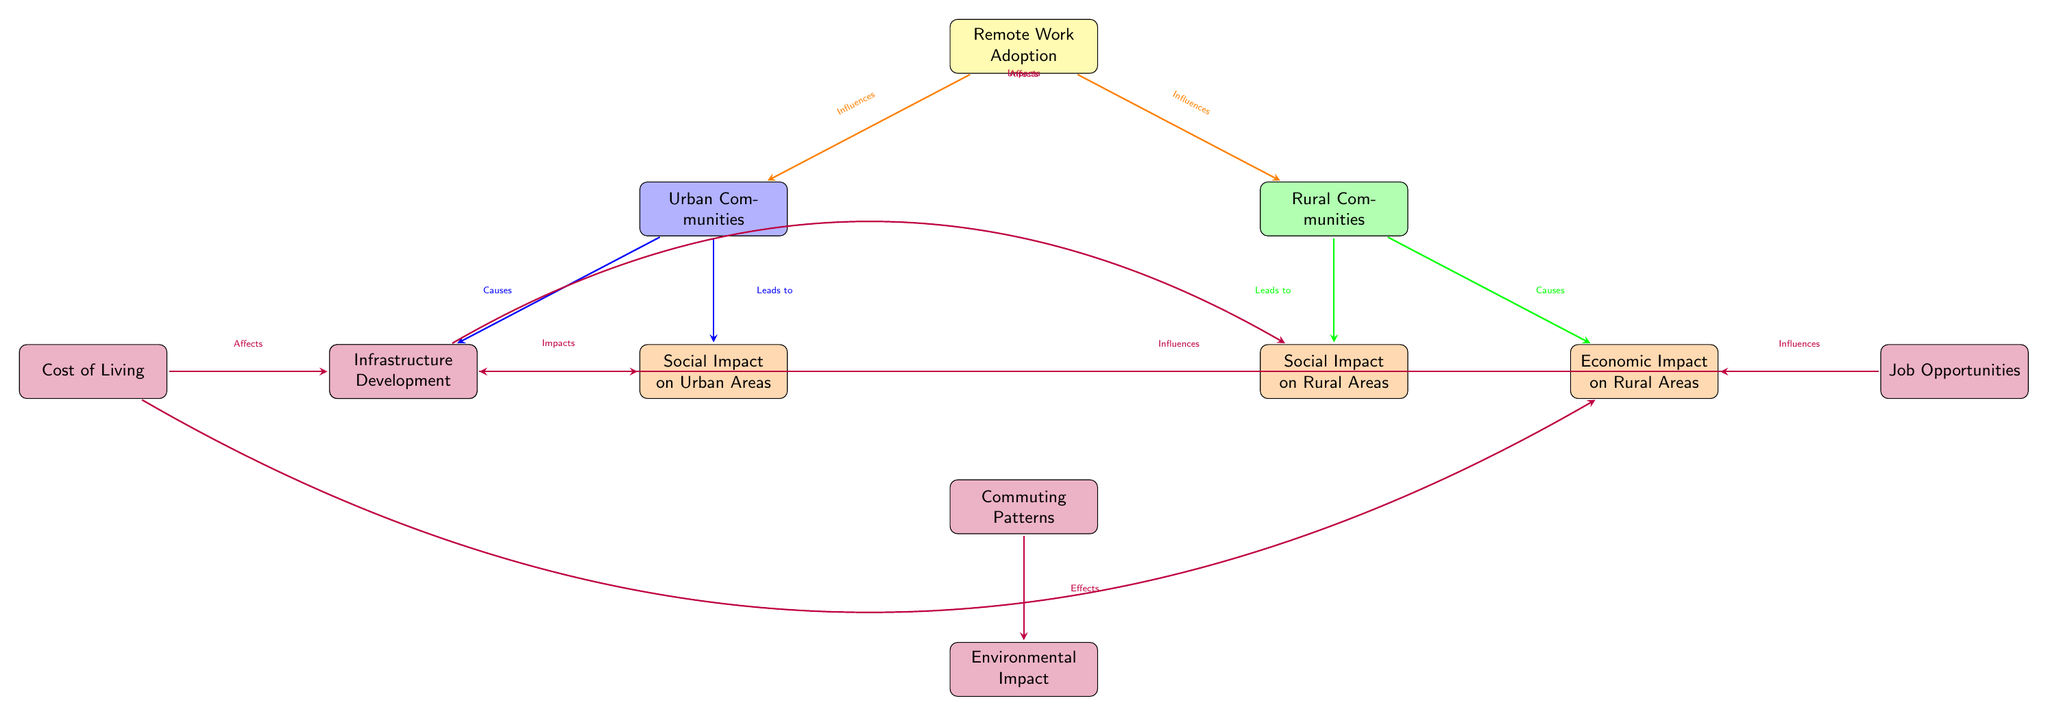What are the two types of communities represented in the diagram? The diagram shows two nodes representing different types of communities: Urban Communities and Rural Communities.
Answer: Urban and Rural How does Remote Work Adoption influence Urban Communities? The arrow from Remote Work Adoption to Urban Communities indicates that it influences them.
Answer: Influences What are the two economic impacts listed for Urban Areas? The diagram shows two nodes connected to Urban Communities: Economic Impact on Urban Areas and Social Impact on Urban Areas.
Answer: Economic Impact and Social Impact What factor affects the Economic Impact on Rural Areas? The arrow indicates that Job Opportunities influences the Economic Impact on Rural Areas.
Answer: Job Opportunities Which factor impacts both Social Impact on Urban Areas and Social Impact on Rural Areas? The Infrastructure Development node shows arrows pointing to both Social Impact nodes, indicating it impacts them.
Answer: Infrastructure Development What environmental aspect is affected by commuting patterns? The diagram shows an arrow from Commuting Patterns flowing down to Environmental Impact, indicating the effect.
Answer: Environmental Impact How many factors are listed that affect Economic Impact on Urban Areas? There are three factors listed: Cost of Living, Job Opportunities, and Infrastructure Development, indicating multiple influences.
Answer: Three Which community type has a higher number of impacts listed? The diagram shows that both Urban and Rural Communities have impact nodes; however, Urban Communities have two social impacts while Rural has one.
Answer: Urban Communities What is the last node in the hierarchy that Environmental Impact is linked to? Environmental Impact is connected below the Commuting Patterns node, indicating the final aspect in that flow.
Answer: Commuting Patterns 